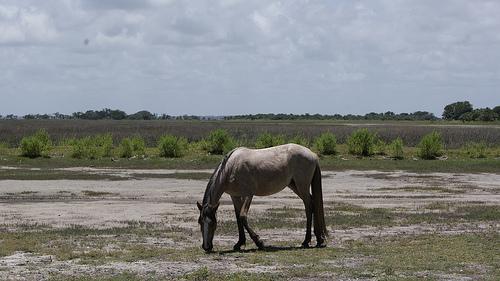How many horses are there?
Give a very brief answer. 1. How many horses are in the field?
Give a very brief answer. 1. 